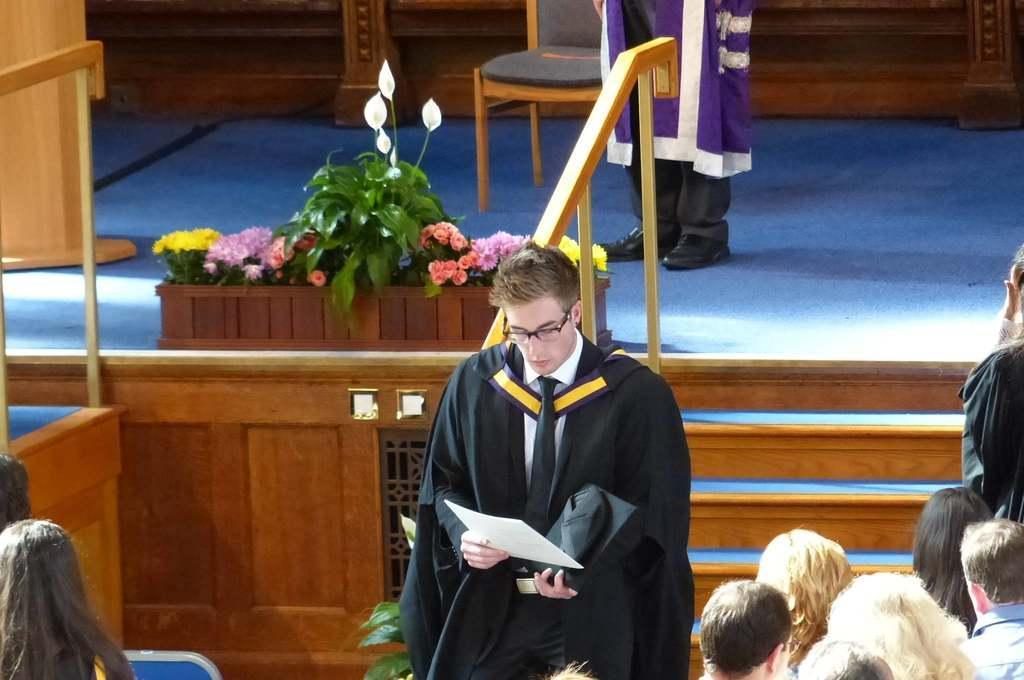Describe this image in one or two sentences. This person is holding a paper and looking into it. On this stage we can see a person, chair and plant. Left side of the image and right side of the image we can see people. 